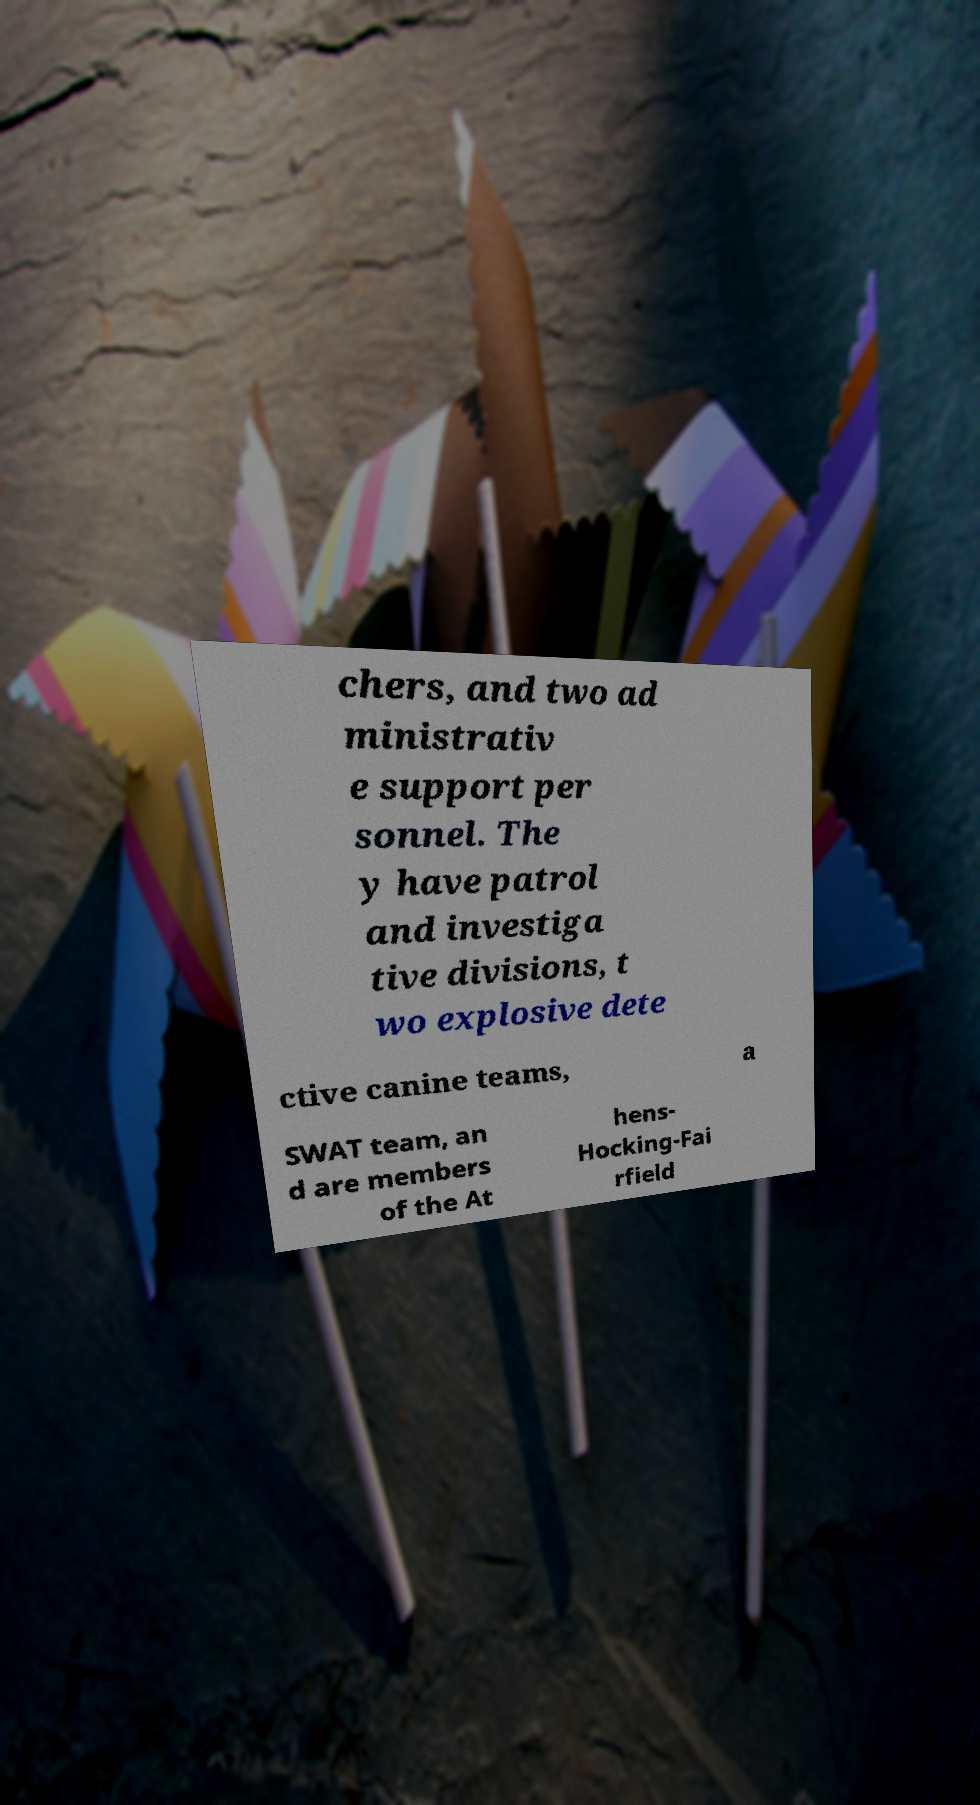Please identify and transcribe the text found in this image. chers, and two ad ministrativ e support per sonnel. The y have patrol and investiga tive divisions, t wo explosive dete ctive canine teams, a SWAT team, an d are members of the At hens- Hocking-Fai rfield 